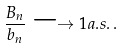<formula> <loc_0><loc_0><loc_500><loc_500>\frac { B _ { n } } { b _ { n } } \longrightarrow 1 a . s . \, .</formula> 